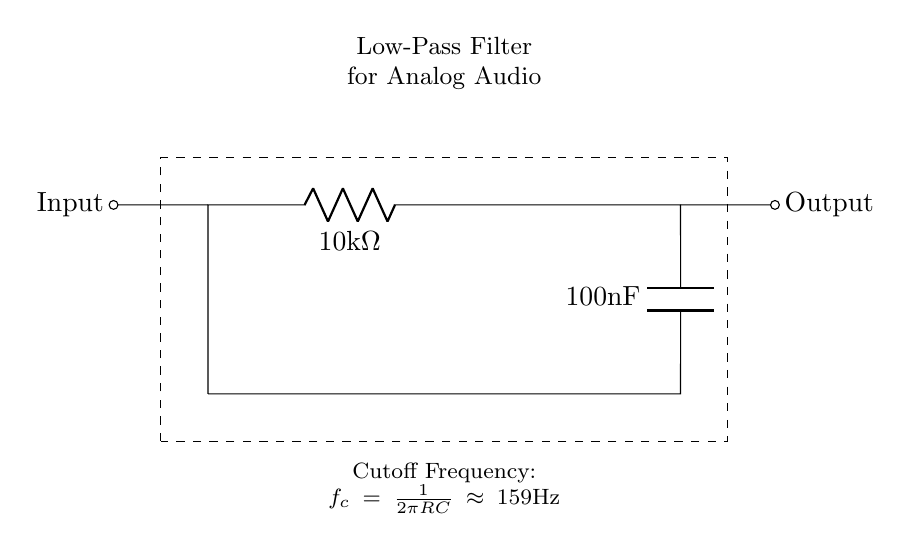What are the components of this circuit? The circuit includes a resistor and a capacitor, which can be identified in the diagram as labeled components. The resistor is marked with a value of 10 kilohms, and the capacitor is labeled as 100 nanofarads.
Answer: Resistor and Capacitor What is the value of the resistor? The resistor is clearly labeled in the circuit diagram with a value of 10 kilohms, which is indicated in the component symbol.
Answer: 10 kilohms What is the capacitor value? The circuit shows the capacitor labeled as 100 nanofarads, which is visible next to the component symbol in the diagram.
Answer: 100 nanofarads What is the cutoff frequency of the filter? The cutoff frequency is given in the circuit diagram as part of the descriptive text at the bottom, calculated using the provided formula for cutoff frequency. Here, it is indicated as approximately 159 Hertz.
Answer: 159 Hertz How does increasing the resistance affect the cutoff frequency? Increasing the resistance in a low-pass filter decreases the cutoff frequency because the formula for cutoff frequency is inversely proportional to resistance. If resistance increases, the value of the cutoff frequency decreases, allowing lower frequencies to pass through effectively while reducing the higher frequencies.
Answer: Decreases cutoff frequency What type of filter is depicted in the circuit? The circuit is designed as a low-pass filter, which is identified in the title at the top of the diagram, indicating its function to allow low frequencies while attenuating high frequencies.
Answer: Low-pass filter What is the function of this circuit in an audio system? This circuit serves to reduce high-frequency noise in analog audio systems, helping to clean up the audio signal and improve sound quality by filtering out unwanted high-frequency components, as indicated in the title.
Answer: Reduce high-frequency noise 